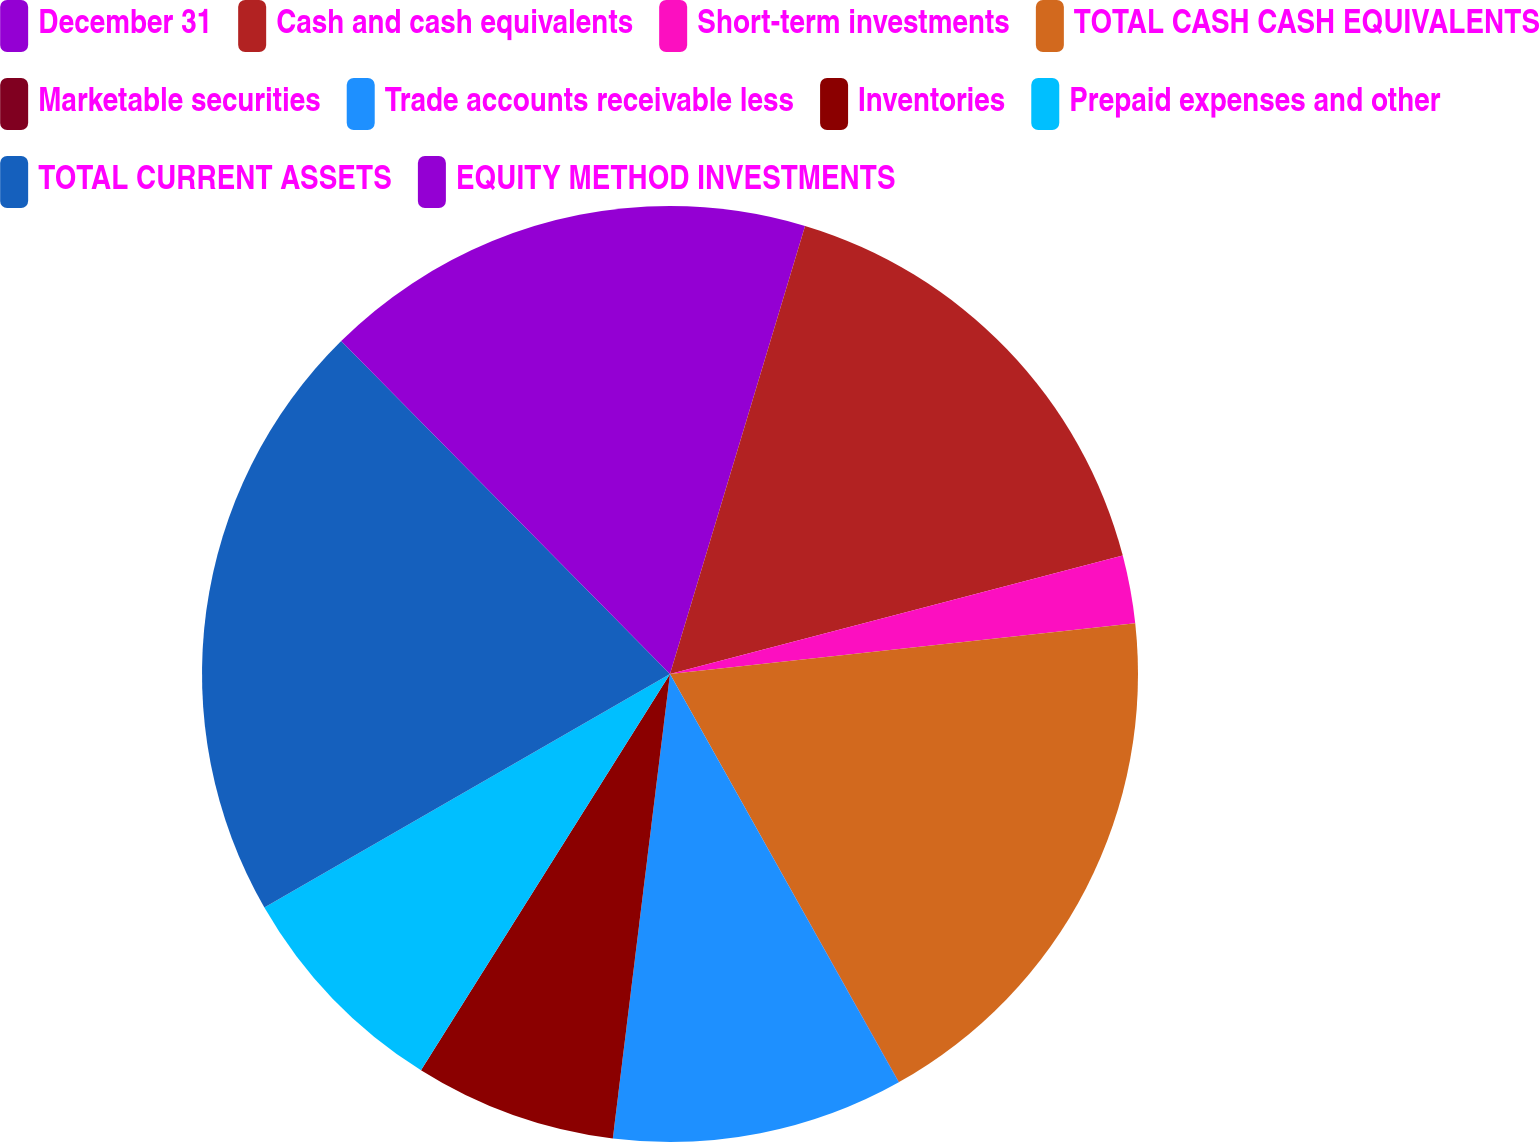Convert chart. <chart><loc_0><loc_0><loc_500><loc_500><pie_chart><fcel>December 31<fcel>Cash and cash equivalents<fcel>Short-term investments<fcel>TOTAL CASH CASH EQUIVALENTS<fcel>Marketable securities<fcel>Trade accounts receivable less<fcel>Inventories<fcel>Prepaid expenses and other<fcel>TOTAL CURRENT ASSETS<fcel>EQUITY METHOD INVESTMENTS<nl><fcel>4.66%<fcel>16.27%<fcel>2.34%<fcel>18.59%<fcel>0.01%<fcel>10.08%<fcel>6.98%<fcel>7.76%<fcel>20.91%<fcel>12.4%<nl></chart> 